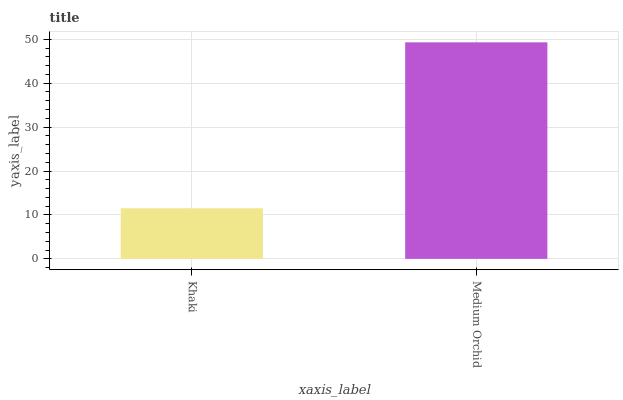Is Khaki the minimum?
Answer yes or no. Yes. Is Medium Orchid the maximum?
Answer yes or no. Yes. Is Medium Orchid the minimum?
Answer yes or no. No. Is Medium Orchid greater than Khaki?
Answer yes or no. Yes. Is Khaki less than Medium Orchid?
Answer yes or no. Yes. Is Khaki greater than Medium Orchid?
Answer yes or no. No. Is Medium Orchid less than Khaki?
Answer yes or no. No. Is Medium Orchid the high median?
Answer yes or no. Yes. Is Khaki the low median?
Answer yes or no. Yes. Is Khaki the high median?
Answer yes or no. No. Is Medium Orchid the low median?
Answer yes or no. No. 